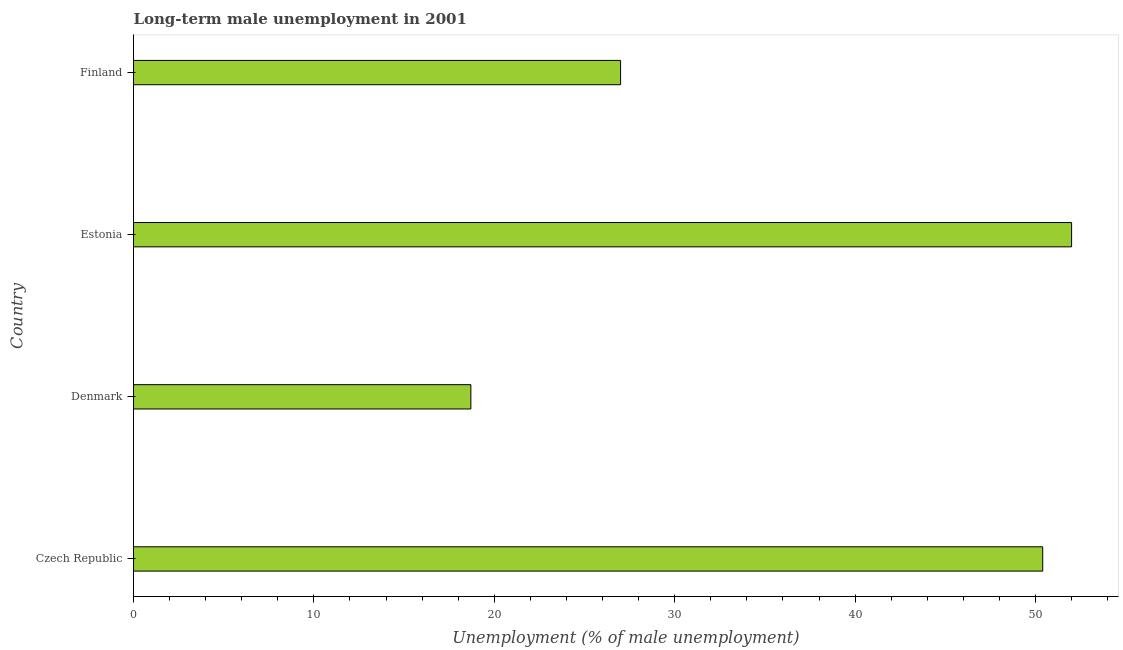Does the graph contain grids?
Provide a short and direct response. No. What is the title of the graph?
Provide a succinct answer. Long-term male unemployment in 2001. What is the label or title of the X-axis?
Make the answer very short. Unemployment (% of male unemployment). What is the label or title of the Y-axis?
Ensure brevity in your answer.  Country. Across all countries, what is the maximum long-term male unemployment?
Ensure brevity in your answer.  52. Across all countries, what is the minimum long-term male unemployment?
Provide a short and direct response. 18.7. In which country was the long-term male unemployment maximum?
Provide a short and direct response. Estonia. In which country was the long-term male unemployment minimum?
Give a very brief answer. Denmark. What is the sum of the long-term male unemployment?
Your response must be concise. 148.1. What is the difference between the long-term male unemployment in Denmark and Estonia?
Offer a terse response. -33.3. What is the average long-term male unemployment per country?
Your answer should be very brief. 37.02. What is the median long-term male unemployment?
Your answer should be compact. 38.7. In how many countries, is the long-term male unemployment greater than 48 %?
Keep it short and to the point. 2. What is the ratio of the long-term male unemployment in Denmark to that in Estonia?
Your response must be concise. 0.36. Is the long-term male unemployment in Denmark less than that in Estonia?
Give a very brief answer. Yes. Is the difference between the long-term male unemployment in Czech Republic and Finland greater than the difference between any two countries?
Provide a succinct answer. No. What is the difference between the highest and the second highest long-term male unemployment?
Your answer should be compact. 1.6. Is the sum of the long-term male unemployment in Denmark and Estonia greater than the maximum long-term male unemployment across all countries?
Ensure brevity in your answer.  Yes. What is the difference between the highest and the lowest long-term male unemployment?
Your answer should be compact. 33.3. In how many countries, is the long-term male unemployment greater than the average long-term male unemployment taken over all countries?
Ensure brevity in your answer.  2. What is the Unemployment (% of male unemployment) of Czech Republic?
Make the answer very short. 50.4. What is the Unemployment (% of male unemployment) in Denmark?
Offer a very short reply. 18.7. What is the Unemployment (% of male unemployment) in Finland?
Your answer should be very brief. 27. What is the difference between the Unemployment (% of male unemployment) in Czech Republic and Denmark?
Give a very brief answer. 31.7. What is the difference between the Unemployment (% of male unemployment) in Czech Republic and Estonia?
Make the answer very short. -1.6. What is the difference between the Unemployment (% of male unemployment) in Czech Republic and Finland?
Keep it short and to the point. 23.4. What is the difference between the Unemployment (% of male unemployment) in Denmark and Estonia?
Your answer should be compact. -33.3. What is the difference between the Unemployment (% of male unemployment) in Estonia and Finland?
Your response must be concise. 25. What is the ratio of the Unemployment (% of male unemployment) in Czech Republic to that in Denmark?
Offer a terse response. 2.69. What is the ratio of the Unemployment (% of male unemployment) in Czech Republic to that in Finland?
Offer a very short reply. 1.87. What is the ratio of the Unemployment (% of male unemployment) in Denmark to that in Estonia?
Your answer should be compact. 0.36. What is the ratio of the Unemployment (% of male unemployment) in Denmark to that in Finland?
Give a very brief answer. 0.69. What is the ratio of the Unemployment (% of male unemployment) in Estonia to that in Finland?
Provide a succinct answer. 1.93. 